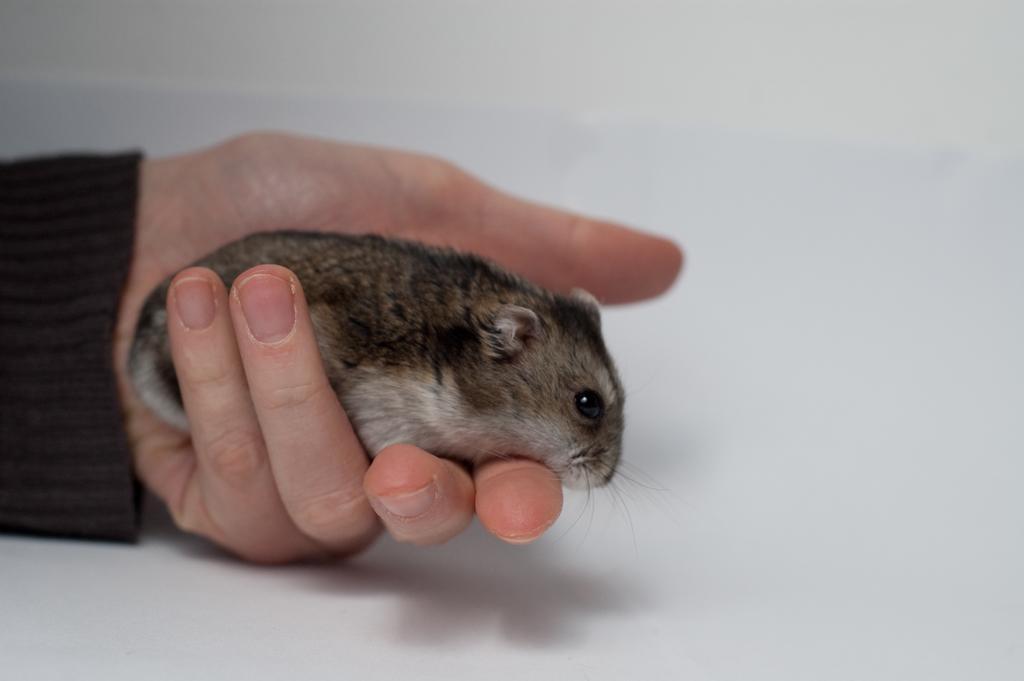Can you describe this image briefly? In this image we can see the hand of a person holding a rat. 